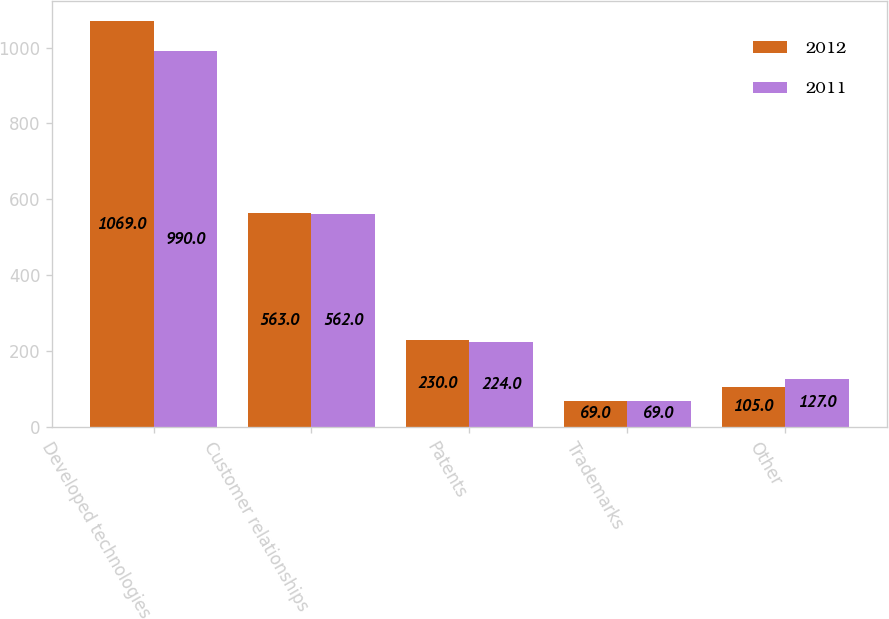Convert chart to OTSL. <chart><loc_0><loc_0><loc_500><loc_500><stacked_bar_chart><ecel><fcel>Developed technologies<fcel>Customer relationships<fcel>Patents<fcel>Trademarks<fcel>Other<nl><fcel>2012<fcel>1069<fcel>563<fcel>230<fcel>69<fcel>105<nl><fcel>2011<fcel>990<fcel>562<fcel>224<fcel>69<fcel>127<nl></chart> 